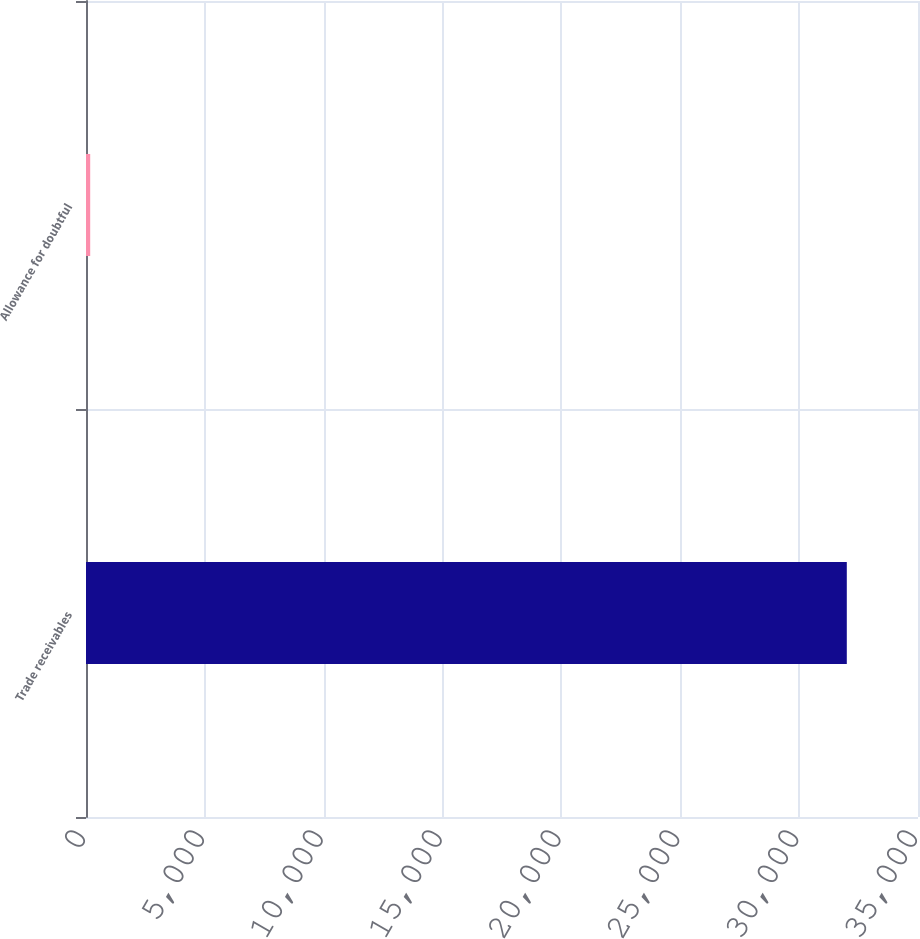Convert chart to OTSL. <chart><loc_0><loc_0><loc_500><loc_500><bar_chart><fcel>Trade receivables<fcel>Allowance for doubtful<nl><fcel>32005<fcel>177<nl></chart> 